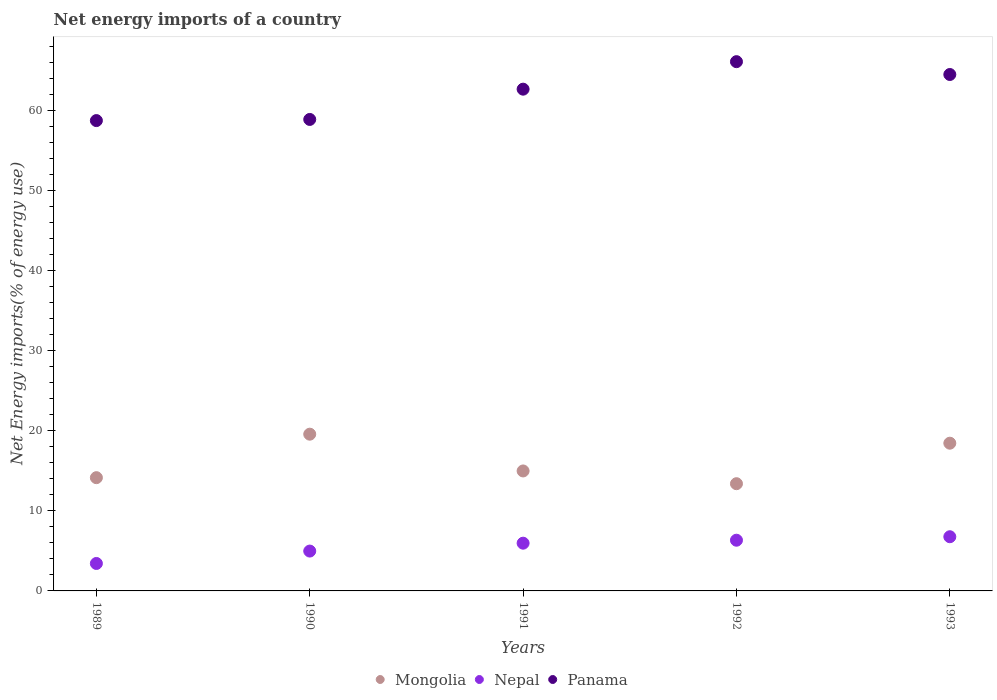How many different coloured dotlines are there?
Your answer should be very brief. 3. Is the number of dotlines equal to the number of legend labels?
Provide a succinct answer. Yes. What is the net energy imports in Mongolia in 1992?
Provide a short and direct response. 13.4. Across all years, what is the maximum net energy imports in Nepal?
Provide a short and direct response. 6.77. Across all years, what is the minimum net energy imports in Nepal?
Ensure brevity in your answer.  3.43. In which year was the net energy imports in Panama maximum?
Provide a short and direct response. 1992. What is the total net energy imports in Panama in the graph?
Your answer should be compact. 311.14. What is the difference between the net energy imports in Mongolia in 1989 and that in 1990?
Provide a short and direct response. -5.44. What is the difference between the net energy imports in Nepal in 1993 and the net energy imports in Panama in 1992?
Offer a very short reply. -59.38. What is the average net energy imports in Nepal per year?
Your answer should be very brief. 5.5. In the year 1991, what is the difference between the net energy imports in Panama and net energy imports in Mongolia?
Ensure brevity in your answer.  47.72. What is the ratio of the net energy imports in Nepal in 1991 to that in 1992?
Offer a terse response. 0.94. Is the difference between the net energy imports in Panama in 1989 and 1993 greater than the difference between the net energy imports in Mongolia in 1989 and 1993?
Your answer should be very brief. No. What is the difference between the highest and the second highest net energy imports in Panama?
Your answer should be compact. 1.6. What is the difference between the highest and the lowest net energy imports in Nepal?
Your answer should be very brief. 3.34. In how many years, is the net energy imports in Mongolia greater than the average net energy imports in Mongolia taken over all years?
Provide a succinct answer. 2. Is it the case that in every year, the sum of the net energy imports in Nepal and net energy imports in Panama  is greater than the net energy imports in Mongolia?
Make the answer very short. Yes. How many years are there in the graph?
Offer a terse response. 5. Does the graph contain any zero values?
Make the answer very short. No. Does the graph contain grids?
Give a very brief answer. No. Where does the legend appear in the graph?
Your response must be concise. Bottom center. How many legend labels are there?
Offer a very short reply. 3. How are the legend labels stacked?
Provide a succinct answer. Horizontal. What is the title of the graph?
Your answer should be compact. Net energy imports of a country. What is the label or title of the Y-axis?
Your answer should be compact. Net Energy imports(% of energy use). What is the Net Energy imports(% of energy use) of Mongolia in 1989?
Ensure brevity in your answer.  14.16. What is the Net Energy imports(% of energy use) in Nepal in 1989?
Make the answer very short. 3.43. What is the Net Energy imports(% of energy use) in Panama in 1989?
Ensure brevity in your answer.  58.79. What is the Net Energy imports(% of energy use) of Mongolia in 1990?
Your response must be concise. 19.59. What is the Net Energy imports(% of energy use) of Nepal in 1990?
Make the answer very short. 4.98. What is the Net Energy imports(% of energy use) of Panama in 1990?
Offer a terse response. 58.93. What is the Net Energy imports(% of energy use) of Mongolia in 1991?
Ensure brevity in your answer.  15. What is the Net Energy imports(% of energy use) of Nepal in 1991?
Keep it short and to the point. 5.97. What is the Net Energy imports(% of energy use) of Panama in 1991?
Offer a terse response. 62.71. What is the Net Energy imports(% of energy use) in Mongolia in 1992?
Offer a terse response. 13.4. What is the Net Energy imports(% of energy use) in Nepal in 1992?
Provide a short and direct response. 6.34. What is the Net Energy imports(% of energy use) in Panama in 1992?
Provide a succinct answer. 66.15. What is the Net Energy imports(% of energy use) of Mongolia in 1993?
Offer a terse response. 18.46. What is the Net Energy imports(% of energy use) in Nepal in 1993?
Provide a short and direct response. 6.77. What is the Net Energy imports(% of energy use) of Panama in 1993?
Give a very brief answer. 64.55. Across all years, what is the maximum Net Energy imports(% of energy use) in Mongolia?
Provide a succinct answer. 19.59. Across all years, what is the maximum Net Energy imports(% of energy use) of Nepal?
Your response must be concise. 6.77. Across all years, what is the maximum Net Energy imports(% of energy use) in Panama?
Give a very brief answer. 66.15. Across all years, what is the minimum Net Energy imports(% of energy use) of Mongolia?
Keep it short and to the point. 13.4. Across all years, what is the minimum Net Energy imports(% of energy use) in Nepal?
Offer a very short reply. 3.43. Across all years, what is the minimum Net Energy imports(% of energy use) of Panama?
Offer a very short reply. 58.79. What is the total Net Energy imports(% of energy use) in Mongolia in the graph?
Give a very brief answer. 80.61. What is the total Net Energy imports(% of energy use) in Nepal in the graph?
Keep it short and to the point. 27.49. What is the total Net Energy imports(% of energy use) of Panama in the graph?
Your answer should be very brief. 311.14. What is the difference between the Net Energy imports(% of energy use) of Mongolia in 1989 and that in 1990?
Provide a short and direct response. -5.44. What is the difference between the Net Energy imports(% of energy use) of Nepal in 1989 and that in 1990?
Offer a terse response. -1.55. What is the difference between the Net Energy imports(% of energy use) of Panama in 1989 and that in 1990?
Your answer should be very brief. -0.14. What is the difference between the Net Energy imports(% of energy use) in Mongolia in 1989 and that in 1991?
Your answer should be very brief. -0.84. What is the difference between the Net Energy imports(% of energy use) of Nepal in 1989 and that in 1991?
Offer a terse response. -2.54. What is the difference between the Net Energy imports(% of energy use) in Panama in 1989 and that in 1991?
Your answer should be compact. -3.93. What is the difference between the Net Energy imports(% of energy use) in Mongolia in 1989 and that in 1992?
Provide a short and direct response. 0.75. What is the difference between the Net Energy imports(% of energy use) in Nepal in 1989 and that in 1992?
Keep it short and to the point. -2.91. What is the difference between the Net Energy imports(% of energy use) in Panama in 1989 and that in 1992?
Offer a very short reply. -7.36. What is the difference between the Net Energy imports(% of energy use) of Mongolia in 1989 and that in 1993?
Offer a terse response. -4.31. What is the difference between the Net Energy imports(% of energy use) of Nepal in 1989 and that in 1993?
Provide a short and direct response. -3.34. What is the difference between the Net Energy imports(% of energy use) in Panama in 1989 and that in 1993?
Offer a very short reply. -5.76. What is the difference between the Net Energy imports(% of energy use) of Mongolia in 1990 and that in 1991?
Your answer should be very brief. 4.6. What is the difference between the Net Energy imports(% of energy use) of Nepal in 1990 and that in 1991?
Provide a succinct answer. -0.99. What is the difference between the Net Energy imports(% of energy use) in Panama in 1990 and that in 1991?
Give a very brief answer. -3.78. What is the difference between the Net Energy imports(% of energy use) in Mongolia in 1990 and that in 1992?
Give a very brief answer. 6.19. What is the difference between the Net Energy imports(% of energy use) in Nepal in 1990 and that in 1992?
Your answer should be compact. -1.36. What is the difference between the Net Energy imports(% of energy use) in Panama in 1990 and that in 1992?
Make the answer very short. -7.22. What is the difference between the Net Energy imports(% of energy use) of Mongolia in 1990 and that in 1993?
Make the answer very short. 1.13. What is the difference between the Net Energy imports(% of energy use) of Nepal in 1990 and that in 1993?
Offer a very short reply. -1.79. What is the difference between the Net Energy imports(% of energy use) in Panama in 1990 and that in 1993?
Provide a succinct answer. -5.62. What is the difference between the Net Energy imports(% of energy use) of Mongolia in 1991 and that in 1992?
Offer a very short reply. 1.59. What is the difference between the Net Energy imports(% of energy use) in Nepal in 1991 and that in 1992?
Keep it short and to the point. -0.37. What is the difference between the Net Energy imports(% of energy use) of Panama in 1991 and that in 1992?
Ensure brevity in your answer.  -3.44. What is the difference between the Net Energy imports(% of energy use) of Mongolia in 1991 and that in 1993?
Offer a terse response. -3.47. What is the difference between the Net Energy imports(% of energy use) in Nepal in 1991 and that in 1993?
Offer a terse response. -0.81. What is the difference between the Net Energy imports(% of energy use) of Panama in 1991 and that in 1993?
Offer a terse response. -1.83. What is the difference between the Net Energy imports(% of energy use) in Mongolia in 1992 and that in 1993?
Offer a terse response. -5.06. What is the difference between the Net Energy imports(% of energy use) in Nepal in 1992 and that in 1993?
Make the answer very short. -0.44. What is the difference between the Net Energy imports(% of energy use) in Panama in 1992 and that in 1993?
Offer a very short reply. 1.6. What is the difference between the Net Energy imports(% of energy use) of Mongolia in 1989 and the Net Energy imports(% of energy use) of Nepal in 1990?
Make the answer very short. 9.17. What is the difference between the Net Energy imports(% of energy use) of Mongolia in 1989 and the Net Energy imports(% of energy use) of Panama in 1990?
Make the answer very short. -44.78. What is the difference between the Net Energy imports(% of energy use) in Nepal in 1989 and the Net Energy imports(% of energy use) in Panama in 1990?
Provide a succinct answer. -55.5. What is the difference between the Net Energy imports(% of energy use) of Mongolia in 1989 and the Net Energy imports(% of energy use) of Nepal in 1991?
Provide a short and direct response. 8.19. What is the difference between the Net Energy imports(% of energy use) of Mongolia in 1989 and the Net Energy imports(% of energy use) of Panama in 1991?
Offer a very short reply. -48.56. What is the difference between the Net Energy imports(% of energy use) in Nepal in 1989 and the Net Energy imports(% of energy use) in Panama in 1991?
Your response must be concise. -59.28. What is the difference between the Net Energy imports(% of energy use) of Mongolia in 1989 and the Net Energy imports(% of energy use) of Nepal in 1992?
Give a very brief answer. 7.82. What is the difference between the Net Energy imports(% of energy use) of Mongolia in 1989 and the Net Energy imports(% of energy use) of Panama in 1992?
Provide a short and direct response. -52. What is the difference between the Net Energy imports(% of energy use) of Nepal in 1989 and the Net Energy imports(% of energy use) of Panama in 1992?
Ensure brevity in your answer.  -62.72. What is the difference between the Net Energy imports(% of energy use) of Mongolia in 1989 and the Net Energy imports(% of energy use) of Nepal in 1993?
Ensure brevity in your answer.  7.38. What is the difference between the Net Energy imports(% of energy use) in Mongolia in 1989 and the Net Energy imports(% of energy use) in Panama in 1993?
Ensure brevity in your answer.  -50.39. What is the difference between the Net Energy imports(% of energy use) of Nepal in 1989 and the Net Energy imports(% of energy use) of Panama in 1993?
Ensure brevity in your answer.  -61.12. What is the difference between the Net Energy imports(% of energy use) in Mongolia in 1990 and the Net Energy imports(% of energy use) in Nepal in 1991?
Your answer should be very brief. 13.62. What is the difference between the Net Energy imports(% of energy use) of Mongolia in 1990 and the Net Energy imports(% of energy use) of Panama in 1991?
Provide a short and direct response. -43.12. What is the difference between the Net Energy imports(% of energy use) of Nepal in 1990 and the Net Energy imports(% of energy use) of Panama in 1991?
Provide a short and direct response. -57.73. What is the difference between the Net Energy imports(% of energy use) of Mongolia in 1990 and the Net Energy imports(% of energy use) of Nepal in 1992?
Provide a short and direct response. 13.25. What is the difference between the Net Energy imports(% of energy use) of Mongolia in 1990 and the Net Energy imports(% of energy use) of Panama in 1992?
Make the answer very short. -46.56. What is the difference between the Net Energy imports(% of energy use) in Nepal in 1990 and the Net Energy imports(% of energy use) in Panama in 1992?
Make the answer very short. -61.17. What is the difference between the Net Energy imports(% of energy use) in Mongolia in 1990 and the Net Energy imports(% of energy use) in Nepal in 1993?
Ensure brevity in your answer.  12.82. What is the difference between the Net Energy imports(% of energy use) of Mongolia in 1990 and the Net Energy imports(% of energy use) of Panama in 1993?
Offer a terse response. -44.96. What is the difference between the Net Energy imports(% of energy use) of Nepal in 1990 and the Net Energy imports(% of energy use) of Panama in 1993?
Your answer should be very brief. -59.57. What is the difference between the Net Energy imports(% of energy use) in Mongolia in 1991 and the Net Energy imports(% of energy use) in Nepal in 1992?
Your answer should be compact. 8.66. What is the difference between the Net Energy imports(% of energy use) in Mongolia in 1991 and the Net Energy imports(% of energy use) in Panama in 1992?
Make the answer very short. -51.16. What is the difference between the Net Energy imports(% of energy use) in Nepal in 1991 and the Net Energy imports(% of energy use) in Panama in 1992?
Offer a terse response. -60.19. What is the difference between the Net Energy imports(% of energy use) in Mongolia in 1991 and the Net Energy imports(% of energy use) in Nepal in 1993?
Your answer should be compact. 8.22. What is the difference between the Net Energy imports(% of energy use) of Mongolia in 1991 and the Net Energy imports(% of energy use) of Panama in 1993?
Your answer should be very brief. -49.55. What is the difference between the Net Energy imports(% of energy use) in Nepal in 1991 and the Net Energy imports(% of energy use) in Panama in 1993?
Offer a very short reply. -58.58. What is the difference between the Net Energy imports(% of energy use) of Mongolia in 1992 and the Net Energy imports(% of energy use) of Nepal in 1993?
Your response must be concise. 6.63. What is the difference between the Net Energy imports(% of energy use) in Mongolia in 1992 and the Net Energy imports(% of energy use) in Panama in 1993?
Give a very brief answer. -51.15. What is the difference between the Net Energy imports(% of energy use) of Nepal in 1992 and the Net Energy imports(% of energy use) of Panama in 1993?
Provide a succinct answer. -58.21. What is the average Net Energy imports(% of energy use) of Mongolia per year?
Your answer should be very brief. 16.12. What is the average Net Energy imports(% of energy use) in Nepal per year?
Offer a terse response. 5.5. What is the average Net Energy imports(% of energy use) in Panama per year?
Keep it short and to the point. 62.23. In the year 1989, what is the difference between the Net Energy imports(% of energy use) of Mongolia and Net Energy imports(% of energy use) of Nepal?
Your answer should be compact. 10.72. In the year 1989, what is the difference between the Net Energy imports(% of energy use) in Mongolia and Net Energy imports(% of energy use) in Panama?
Make the answer very short. -44.63. In the year 1989, what is the difference between the Net Energy imports(% of energy use) in Nepal and Net Energy imports(% of energy use) in Panama?
Your answer should be compact. -55.36. In the year 1990, what is the difference between the Net Energy imports(% of energy use) in Mongolia and Net Energy imports(% of energy use) in Nepal?
Your response must be concise. 14.61. In the year 1990, what is the difference between the Net Energy imports(% of energy use) of Mongolia and Net Energy imports(% of energy use) of Panama?
Your response must be concise. -39.34. In the year 1990, what is the difference between the Net Energy imports(% of energy use) of Nepal and Net Energy imports(% of energy use) of Panama?
Your response must be concise. -53.95. In the year 1991, what is the difference between the Net Energy imports(% of energy use) of Mongolia and Net Energy imports(% of energy use) of Nepal?
Offer a very short reply. 9.03. In the year 1991, what is the difference between the Net Energy imports(% of energy use) of Mongolia and Net Energy imports(% of energy use) of Panama?
Offer a terse response. -47.72. In the year 1991, what is the difference between the Net Energy imports(% of energy use) of Nepal and Net Energy imports(% of energy use) of Panama?
Provide a succinct answer. -56.75. In the year 1992, what is the difference between the Net Energy imports(% of energy use) in Mongolia and Net Energy imports(% of energy use) in Nepal?
Provide a succinct answer. 7.06. In the year 1992, what is the difference between the Net Energy imports(% of energy use) in Mongolia and Net Energy imports(% of energy use) in Panama?
Provide a succinct answer. -52.75. In the year 1992, what is the difference between the Net Energy imports(% of energy use) in Nepal and Net Energy imports(% of energy use) in Panama?
Offer a very short reply. -59.82. In the year 1993, what is the difference between the Net Energy imports(% of energy use) in Mongolia and Net Energy imports(% of energy use) in Nepal?
Ensure brevity in your answer.  11.69. In the year 1993, what is the difference between the Net Energy imports(% of energy use) of Mongolia and Net Energy imports(% of energy use) of Panama?
Offer a terse response. -46.08. In the year 1993, what is the difference between the Net Energy imports(% of energy use) in Nepal and Net Energy imports(% of energy use) in Panama?
Your answer should be compact. -57.78. What is the ratio of the Net Energy imports(% of energy use) of Mongolia in 1989 to that in 1990?
Keep it short and to the point. 0.72. What is the ratio of the Net Energy imports(% of energy use) of Nepal in 1989 to that in 1990?
Provide a short and direct response. 0.69. What is the ratio of the Net Energy imports(% of energy use) in Mongolia in 1989 to that in 1991?
Your response must be concise. 0.94. What is the ratio of the Net Energy imports(% of energy use) of Nepal in 1989 to that in 1991?
Your answer should be compact. 0.58. What is the ratio of the Net Energy imports(% of energy use) in Panama in 1989 to that in 1991?
Provide a succinct answer. 0.94. What is the ratio of the Net Energy imports(% of energy use) in Mongolia in 1989 to that in 1992?
Offer a terse response. 1.06. What is the ratio of the Net Energy imports(% of energy use) of Nepal in 1989 to that in 1992?
Make the answer very short. 0.54. What is the ratio of the Net Energy imports(% of energy use) of Panama in 1989 to that in 1992?
Offer a terse response. 0.89. What is the ratio of the Net Energy imports(% of energy use) of Mongolia in 1989 to that in 1993?
Keep it short and to the point. 0.77. What is the ratio of the Net Energy imports(% of energy use) of Nepal in 1989 to that in 1993?
Make the answer very short. 0.51. What is the ratio of the Net Energy imports(% of energy use) in Panama in 1989 to that in 1993?
Ensure brevity in your answer.  0.91. What is the ratio of the Net Energy imports(% of energy use) in Mongolia in 1990 to that in 1991?
Keep it short and to the point. 1.31. What is the ratio of the Net Energy imports(% of energy use) in Nepal in 1990 to that in 1991?
Ensure brevity in your answer.  0.83. What is the ratio of the Net Energy imports(% of energy use) in Panama in 1990 to that in 1991?
Ensure brevity in your answer.  0.94. What is the ratio of the Net Energy imports(% of energy use) in Mongolia in 1990 to that in 1992?
Your answer should be very brief. 1.46. What is the ratio of the Net Energy imports(% of energy use) in Nepal in 1990 to that in 1992?
Provide a succinct answer. 0.79. What is the ratio of the Net Energy imports(% of energy use) in Panama in 1990 to that in 1992?
Give a very brief answer. 0.89. What is the ratio of the Net Energy imports(% of energy use) in Mongolia in 1990 to that in 1993?
Provide a succinct answer. 1.06. What is the ratio of the Net Energy imports(% of energy use) of Nepal in 1990 to that in 1993?
Ensure brevity in your answer.  0.74. What is the ratio of the Net Energy imports(% of energy use) of Panama in 1990 to that in 1993?
Give a very brief answer. 0.91. What is the ratio of the Net Energy imports(% of energy use) in Mongolia in 1991 to that in 1992?
Provide a succinct answer. 1.12. What is the ratio of the Net Energy imports(% of energy use) of Nepal in 1991 to that in 1992?
Provide a succinct answer. 0.94. What is the ratio of the Net Energy imports(% of energy use) in Panama in 1991 to that in 1992?
Your answer should be compact. 0.95. What is the ratio of the Net Energy imports(% of energy use) of Mongolia in 1991 to that in 1993?
Keep it short and to the point. 0.81. What is the ratio of the Net Energy imports(% of energy use) of Nepal in 1991 to that in 1993?
Provide a succinct answer. 0.88. What is the ratio of the Net Energy imports(% of energy use) of Panama in 1991 to that in 1993?
Offer a terse response. 0.97. What is the ratio of the Net Energy imports(% of energy use) in Mongolia in 1992 to that in 1993?
Offer a terse response. 0.73. What is the ratio of the Net Energy imports(% of energy use) in Nepal in 1992 to that in 1993?
Ensure brevity in your answer.  0.94. What is the ratio of the Net Energy imports(% of energy use) in Panama in 1992 to that in 1993?
Make the answer very short. 1.02. What is the difference between the highest and the second highest Net Energy imports(% of energy use) of Mongolia?
Your response must be concise. 1.13. What is the difference between the highest and the second highest Net Energy imports(% of energy use) of Nepal?
Your answer should be compact. 0.44. What is the difference between the highest and the second highest Net Energy imports(% of energy use) in Panama?
Offer a terse response. 1.6. What is the difference between the highest and the lowest Net Energy imports(% of energy use) in Mongolia?
Provide a short and direct response. 6.19. What is the difference between the highest and the lowest Net Energy imports(% of energy use) in Nepal?
Provide a short and direct response. 3.34. What is the difference between the highest and the lowest Net Energy imports(% of energy use) of Panama?
Keep it short and to the point. 7.36. 